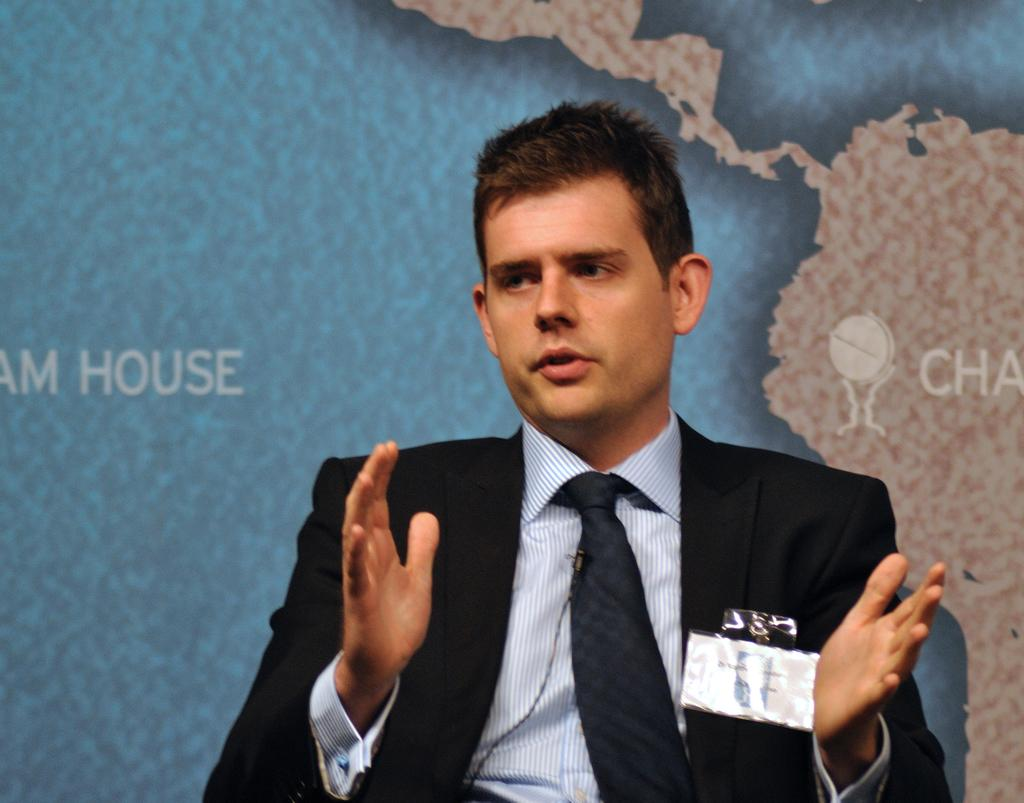What is the person in the image doing? The person is sitting on a chair and explaining something. Can you describe the background of the image? There is a map-like image visible in the background. How many rings are visible on the person's fingers in the image? There is no mention of rings in the image, so we cannot determine the number of rings visible on the person's fingers. 